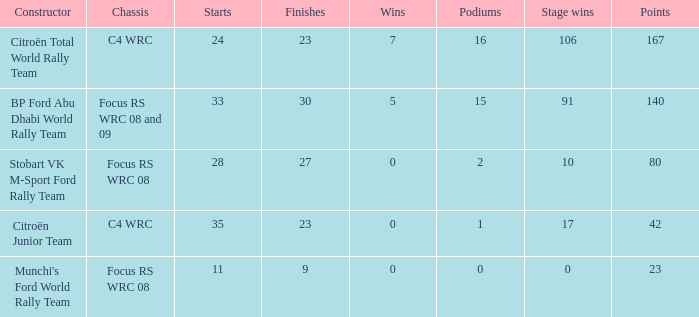What is the highest podiums when the stage wins is 91 and the points is less than 140? None. 